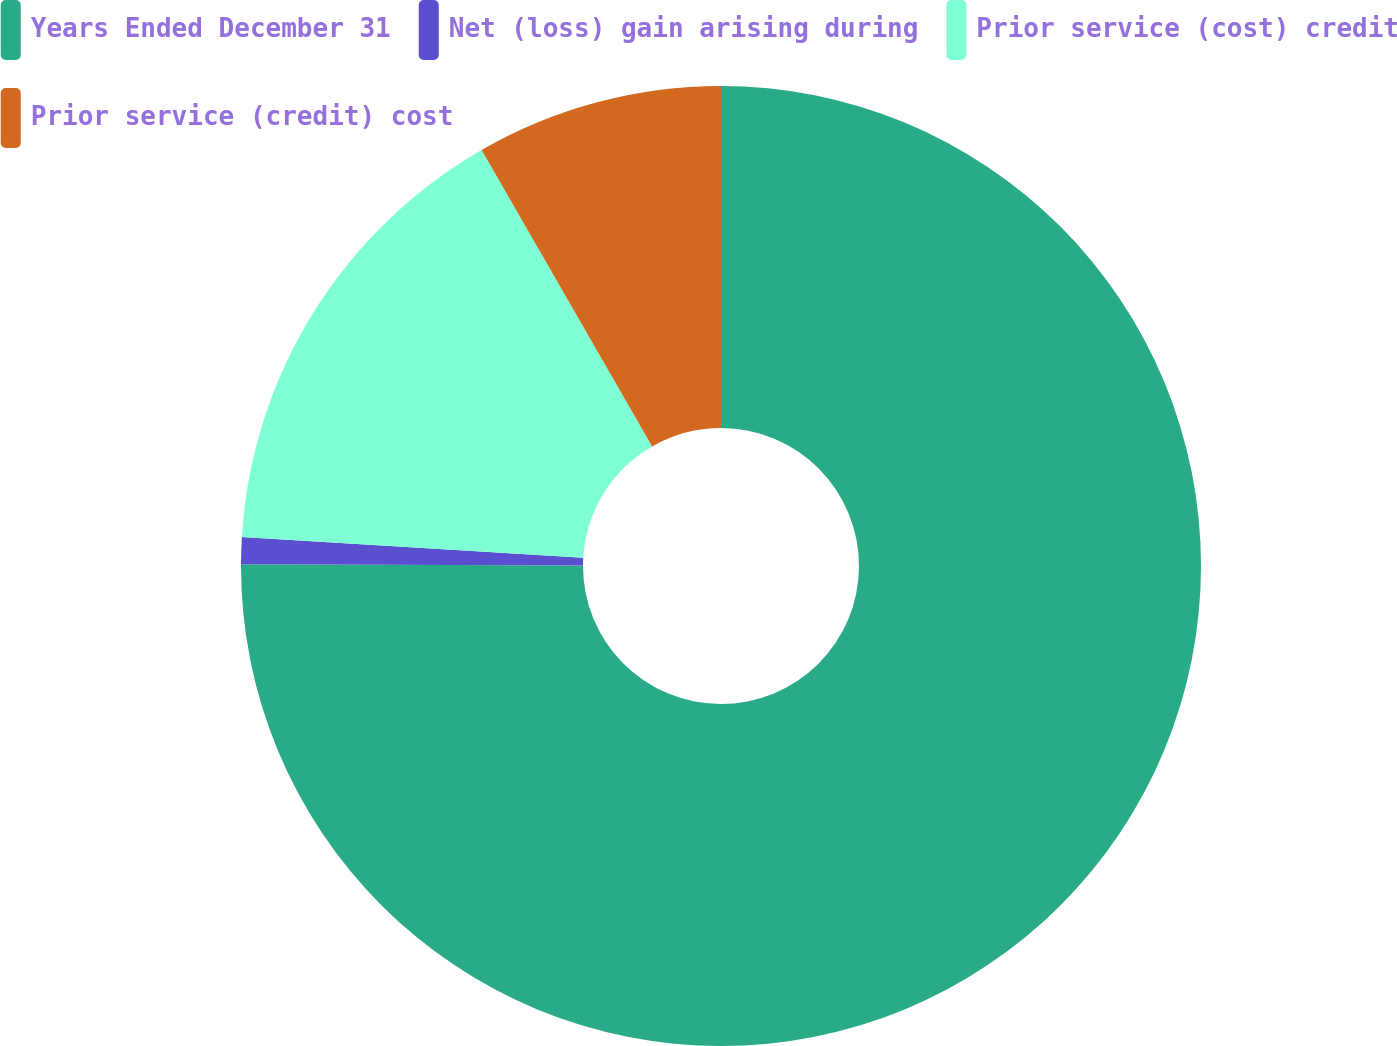Convert chart. <chart><loc_0><loc_0><loc_500><loc_500><pie_chart><fcel>Years Ended December 31<fcel>Net (loss) gain arising during<fcel>Prior service (cost) credit<fcel>Prior service (credit) cost<nl><fcel>75.06%<fcel>0.9%<fcel>15.73%<fcel>8.31%<nl></chart> 